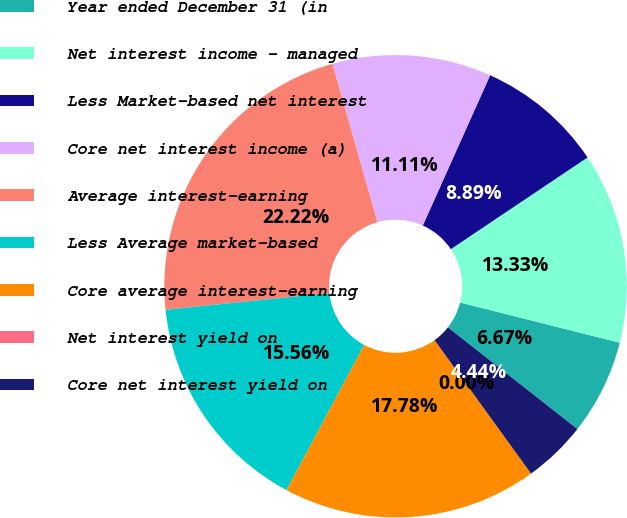Convert chart to OTSL. <chart><loc_0><loc_0><loc_500><loc_500><pie_chart><fcel>Year ended December 31 (in<fcel>Net interest income - managed<fcel>Less Market-based net interest<fcel>Core net interest income (a)<fcel>Average interest-earning<fcel>Less Average market-based<fcel>Core average interest-earning<fcel>Net interest yield on<fcel>Core net interest yield on<nl><fcel>6.67%<fcel>13.33%<fcel>8.89%<fcel>11.11%<fcel>22.22%<fcel>15.56%<fcel>17.78%<fcel>0.0%<fcel>4.44%<nl></chart> 